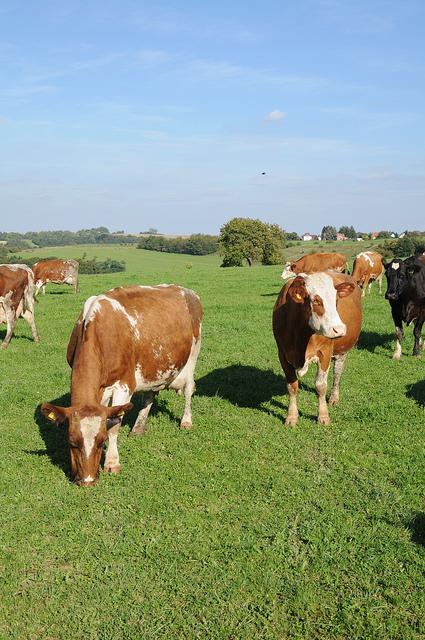Are any of the cows eating?
Concise answer only. Yes. Are this the kind of animals you get milk from?
Write a very short answer. Yes. Which cow has the head down?
Short answer required. Left. What is visible in the background?
Quick response, please. Trees. IS this cow standing?
Quick response, please. Yes. What kind of animals are in the picture?
Answer briefly. Cows. 